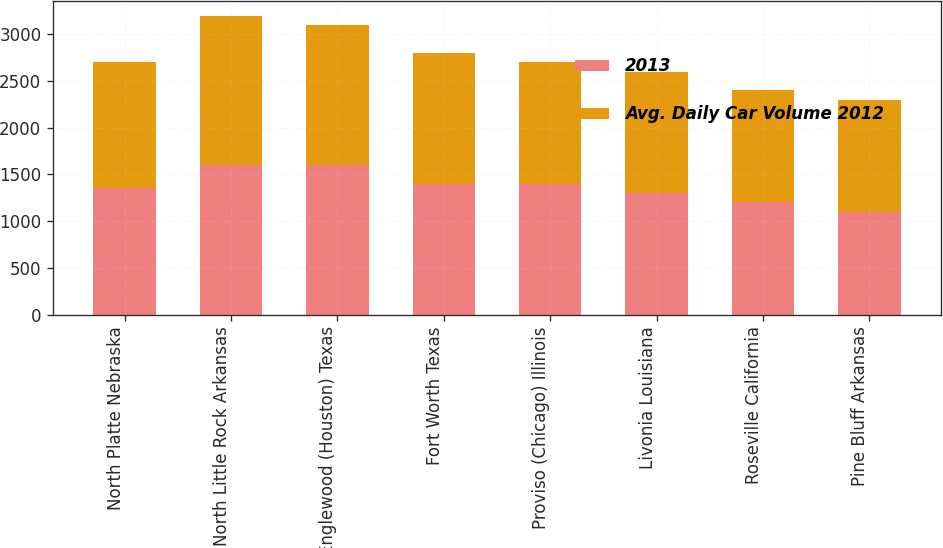Convert chart. <chart><loc_0><loc_0><loc_500><loc_500><stacked_bar_chart><ecel><fcel>North Platte Nebraska<fcel>North Little Rock Arkansas<fcel>Englewood (Houston) Texas<fcel>Fort Worth Texas<fcel>Proviso (Chicago) Illinois<fcel>Livonia Louisiana<fcel>Roseville California<fcel>Pine Bluff Arkansas<nl><fcel>2013<fcel>1350<fcel>1600<fcel>1600<fcel>1400<fcel>1400<fcel>1300<fcel>1200<fcel>1100<nl><fcel>Avg. Daily Car Volume 2012<fcel>1350<fcel>1600<fcel>1500<fcel>1400<fcel>1300<fcel>1300<fcel>1200<fcel>1200<nl></chart> 